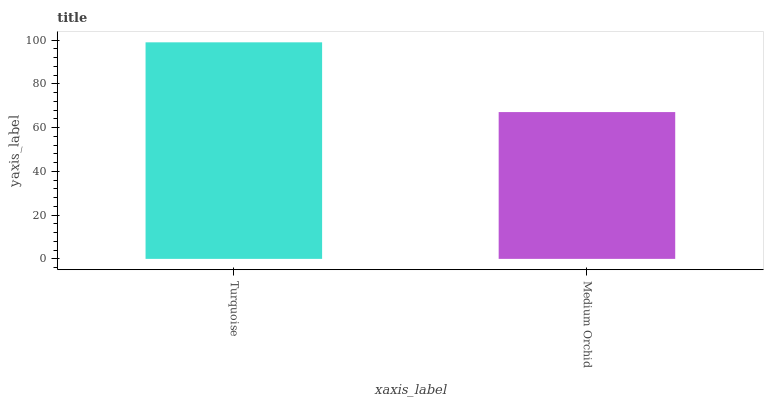Is Medium Orchid the minimum?
Answer yes or no. Yes. Is Turquoise the maximum?
Answer yes or no. Yes. Is Medium Orchid the maximum?
Answer yes or no. No. Is Turquoise greater than Medium Orchid?
Answer yes or no. Yes. Is Medium Orchid less than Turquoise?
Answer yes or no. Yes. Is Medium Orchid greater than Turquoise?
Answer yes or no. No. Is Turquoise less than Medium Orchid?
Answer yes or no. No. Is Turquoise the high median?
Answer yes or no. Yes. Is Medium Orchid the low median?
Answer yes or no. Yes. Is Medium Orchid the high median?
Answer yes or no. No. Is Turquoise the low median?
Answer yes or no. No. 